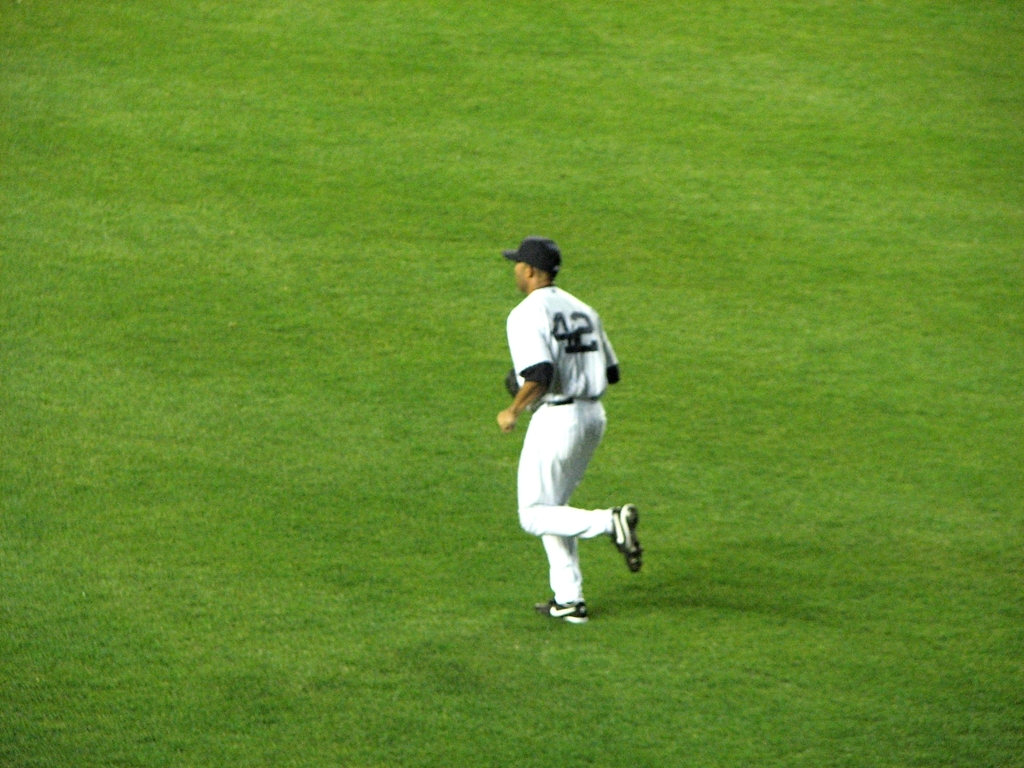Is the background grassland relatively clean?
A. Yes
B. No
Answer with the option's letter from the given choices directly.
 A. 